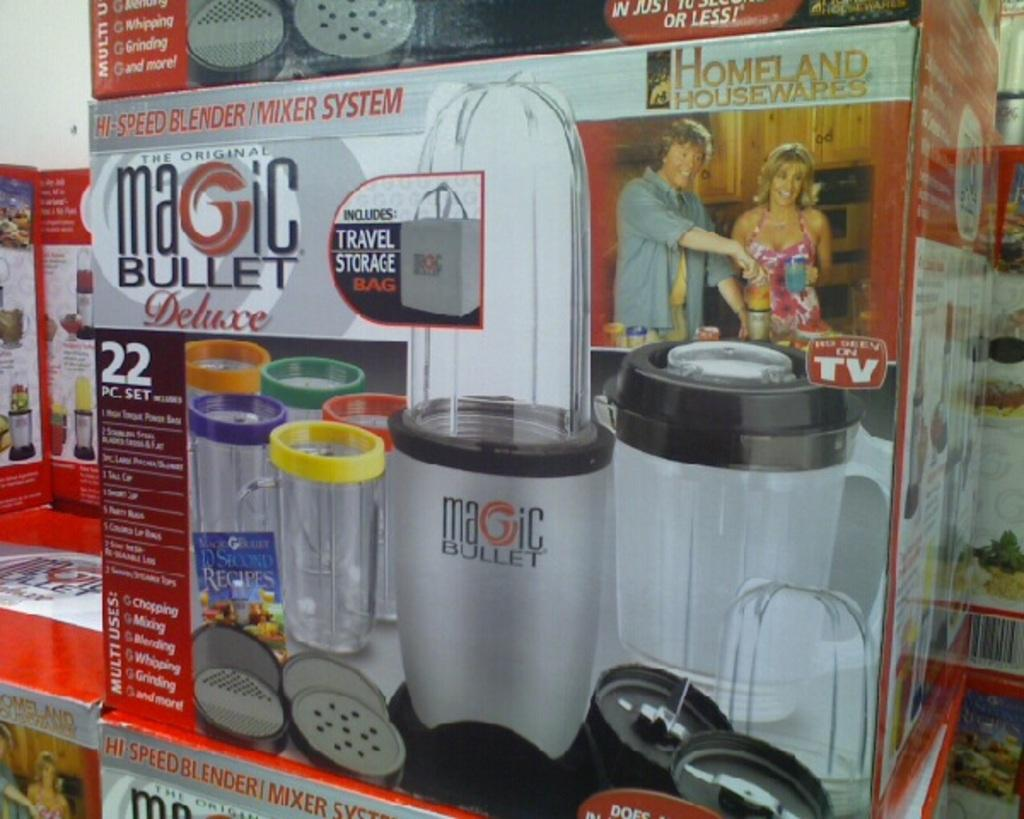<image>
Provide a brief description of the given image. A box for the Magic Bullet Deluxe features canisters with different colored rims. 